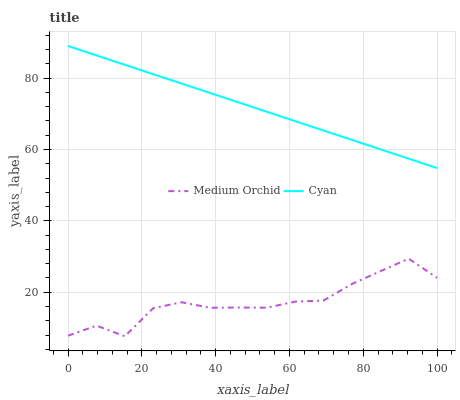Does Medium Orchid have the maximum area under the curve?
Answer yes or no. No. Is Medium Orchid the smoothest?
Answer yes or no. No. Does Medium Orchid have the highest value?
Answer yes or no. No. Is Medium Orchid less than Cyan?
Answer yes or no. Yes. Is Cyan greater than Medium Orchid?
Answer yes or no. Yes. Does Medium Orchid intersect Cyan?
Answer yes or no. No. 